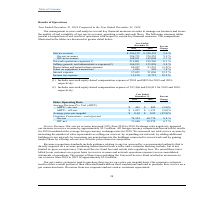From Cogent Communications Group's financial document, What are the respective APRU from on-net in 2018 and 2019? The document shows two values: $ 480 and $ 461. From the document: "Data Average Revenue Per Unit (ARPU) ARPU—on - net $ 461 $ 480 (3.8)% ARPU—off - net $ 1,097 $ 1,155 (5.0)% Average price per megabit $ 0.62 $ 0.82 (2..." Also, What are the respective APRU from off-net in 2018 and 2019? The document shows two values: $ 1,155 and $ 1,155. From the document: "on - net $ 461 $ 480 (3.8)% ARPU—off - net $ 1,097 $ 1,155 (5.0)% Average price per megabit $ 0.62 $ 0.82 (23.9)% Customer Connections—end of period O..." Also, What are the respective average price per megabit in 2018 and 2019? The document shows two values: $ 0.82 and $ 0.62. From the document: "t $ 1,097 $ 1,155 (5.0)% Average price per megabit $ 0.62 $ 0.82 (23.9)% Customer Connections—end of period On - net 74,554 68,770 8.4 % Off - net 11,..." Also, can you calculate: What is the average APRU from on-net in 2018 and 2019? To answer this question, I need to perform calculations using the financial data. The calculation is: (480 + 461)/2 , which equals 470.5. This is based on the information: "age Revenue Per Unit (ARPU) ARPU—on - net $ 461 $ 480 (3.8)% ARPU—off - net $ 1,097 $ 1,155 (5.0)% Average price per megabit $ 0.62 $ 0.82 (23.9)% Custom a Average Revenue Per Unit (ARPU) ARPU—on - ne..." The key data points involved are: 461, 480. Also, can you calculate: What is the average APRU from off-net in 2018 and 2019? To answer this question, I need to perform calculations using the financial data. The calculation is: (1,155 + 1,097)/2, which equals 1126. This is based on the information: "ARPU—on - net $ 461 $ 480 (3.8)% ARPU—off - net $ 1,097 $ 1,155 (5.0)% Average price per megabit $ 0.62 $ 0.82 (23.9)% Customer Connections—end of period O - net $ 461 $ 480 (3.8)% ARPU—off - net $ 1,..." The key data points involved are: 1,097, 1,155. Also, can you calculate: What is the average number of on-net customer connections at the end of the period in 2018 and 2019? To answer this question, I need to perform calculations using the financial data. The calculation is: (68,770 + 74,554)/2 , which equals 71662. This is based on the information: "3.9)% Customer Connections—end of period On - net 74,554 68,770 8.4 % Off - net 11,660 10,974 6.3 % ustomer Connections—end of period On - net 74,554 68,770 8.4 % Off - net 11,660 10,974 6.3 %..." The key data points involved are: 68,770, 74,554. 